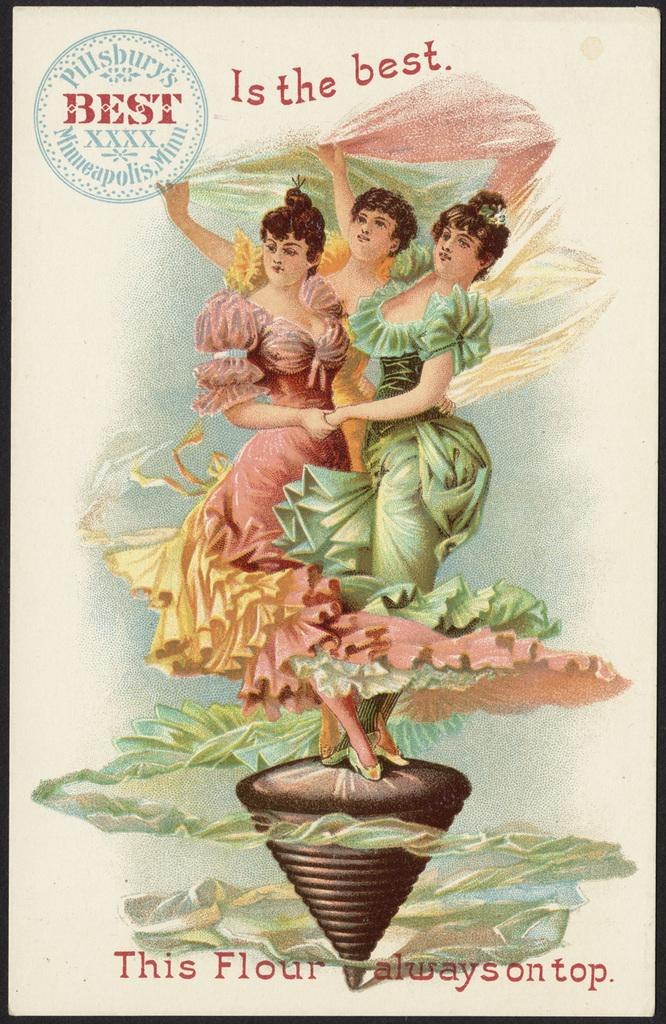<image>
Write a terse but informative summary of the picture. A vintage ad for Pillsbury's best flour showing three women. 